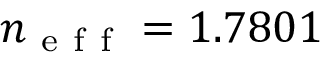Convert formula to latex. <formula><loc_0><loc_0><loc_500><loc_500>n _ { e f f } = 1 . 7 8 0 1</formula> 